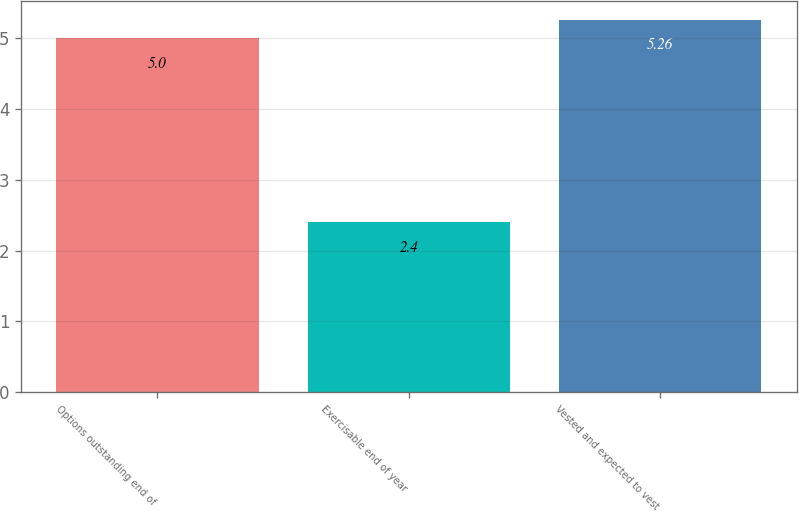Convert chart. <chart><loc_0><loc_0><loc_500><loc_500><bar_chart><fcel>Options outstanding end of<fcel>Exercisable end of year<fcel>Vested and expected to vest<nl><fcel>5<fcel>2.4<fcel>5.26<nl></chart> 